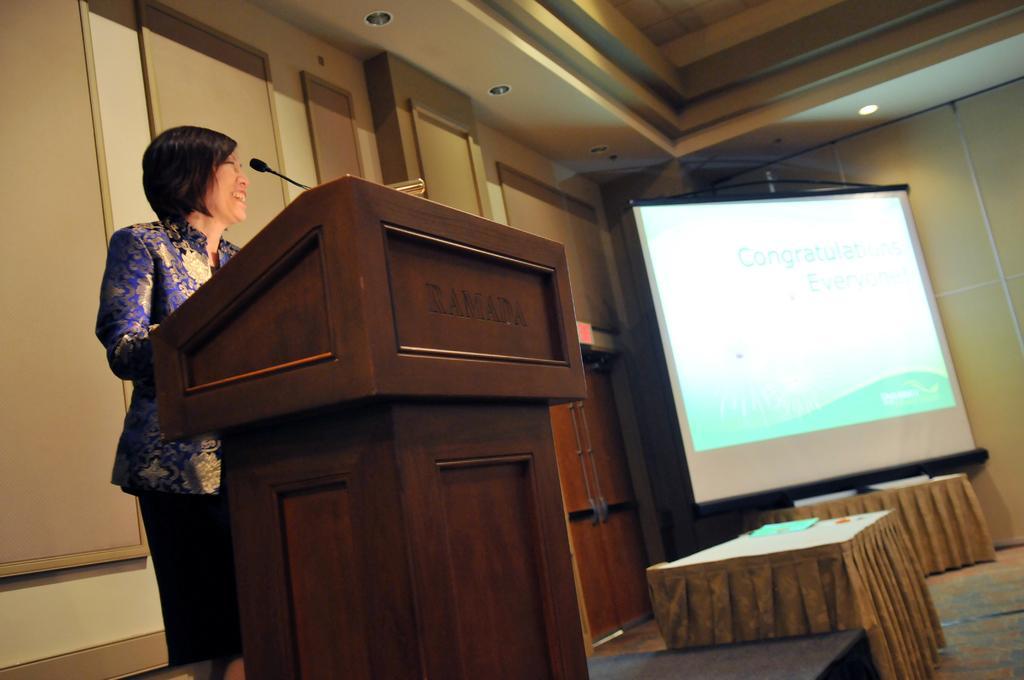Please provide a concise description of this image. In this picture I can see a person standing near the podium, there is a mike, there are tables, screen, lights , and in the background there are frames attached to the wall. 